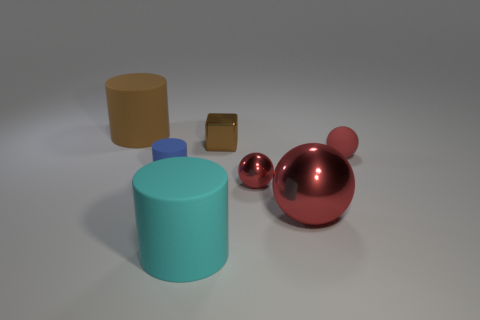Add 1 purple metallic objects. How many objects exist? 8 Subtract all balls. How many objects are left? 4 Subtract all big red cylinders. Subtract all big cyan matte things. How many objects are left? 6 Add 6 tiny rubber cylinders. How many tiny rubber cylinders are left? 7 Add 7 big red balls. How many big red balls exist? 8 Subtract 0 purple spheres. How many objects are left? 7 